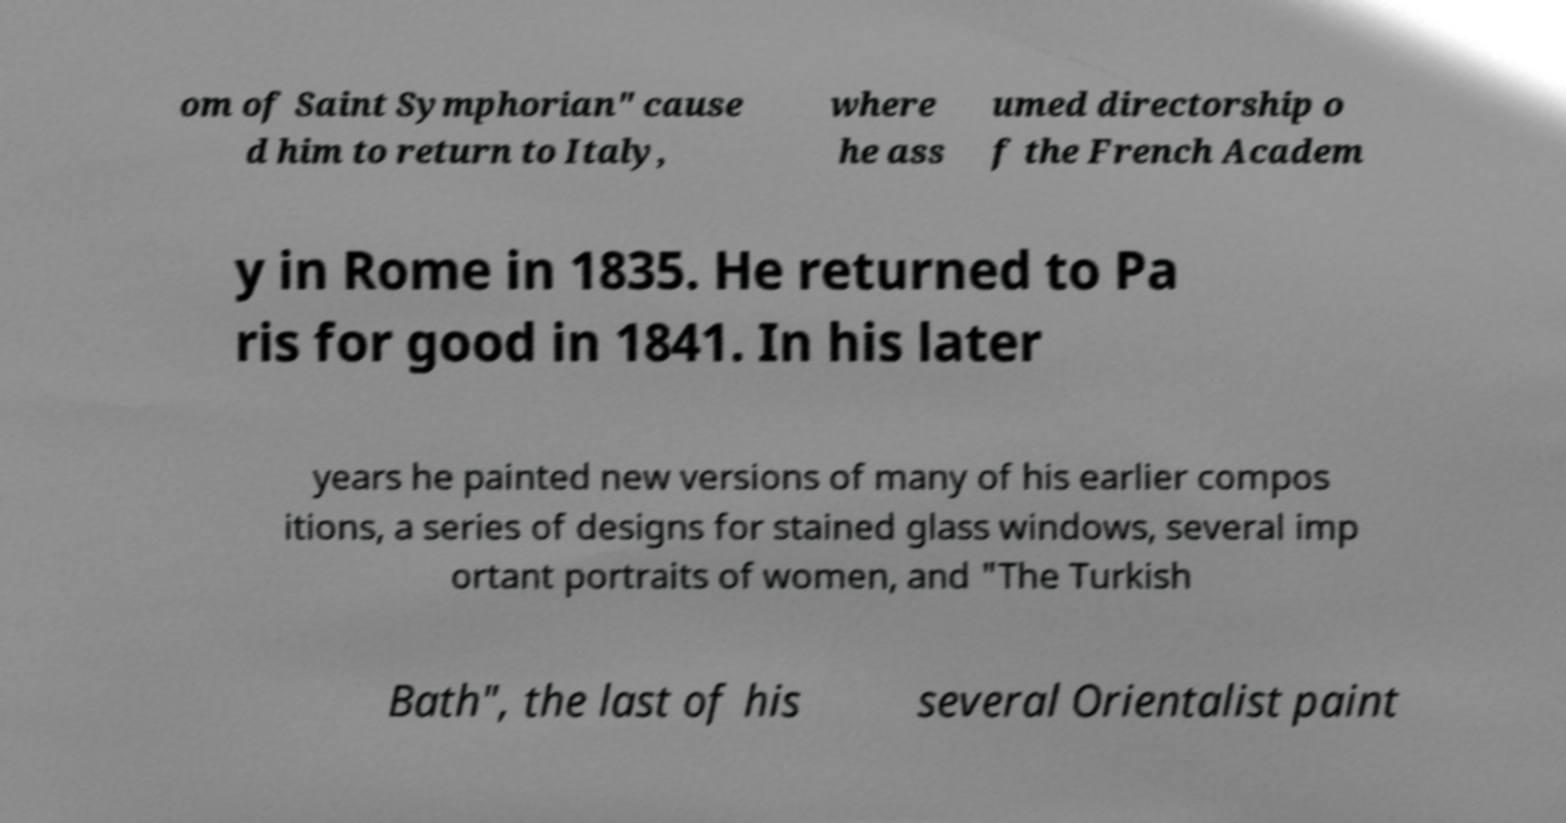There's text embedded in this image that I need extracted. Can you transcribe it verbatim? om of Saint Symphorian" cause d him to return to Italy, where he ass umed directorship o f the French Academ y in Rome in 1835. He returned to Pa ris for good in 1841. In his later years he painted new versions of many of his earlier compos itions, a series of designs for stained glass windows, several imp ortant portraits of women, and "The Turkish Bath", the last of his several Orientalist paint 